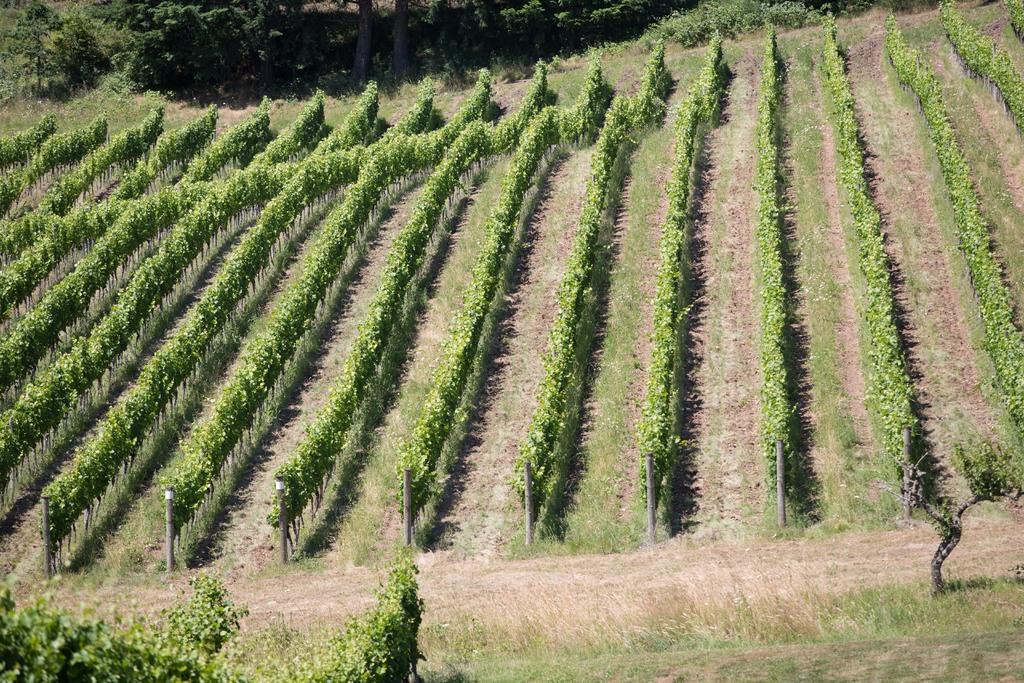Can you describe this image briefly? In this image I can see few poles and I can also see the plants and trees in green color. 